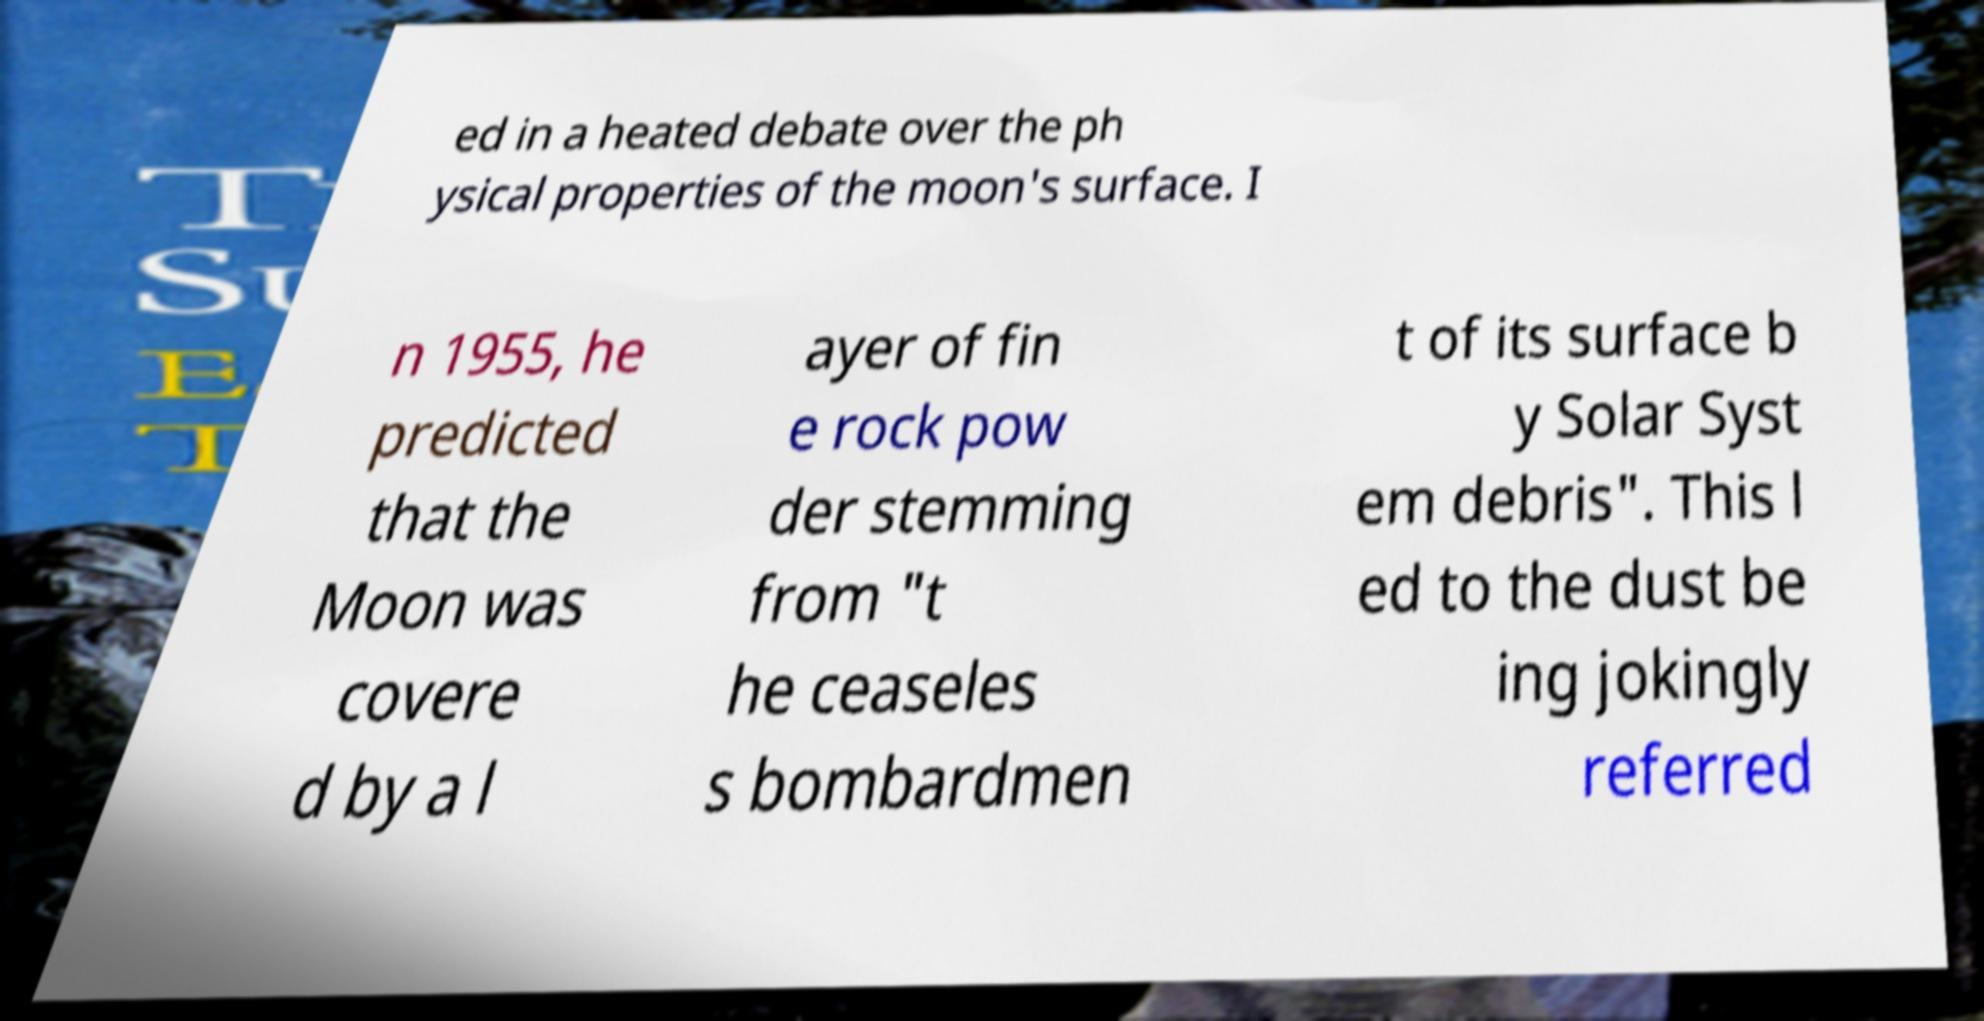There's text embedded in this image that I need extracted. Can you transcribe it verbatim? ed in a heated debate over the ph ysical properties of the moon's surface. I n 1955, he predicted that the Moon was covere d by a l ayer of fin e rock pow der stemming from "t he ceaseles s bombardmen t of its surface b y Solar Syst em debris". This l ed to the dust be ing jokingly referred 